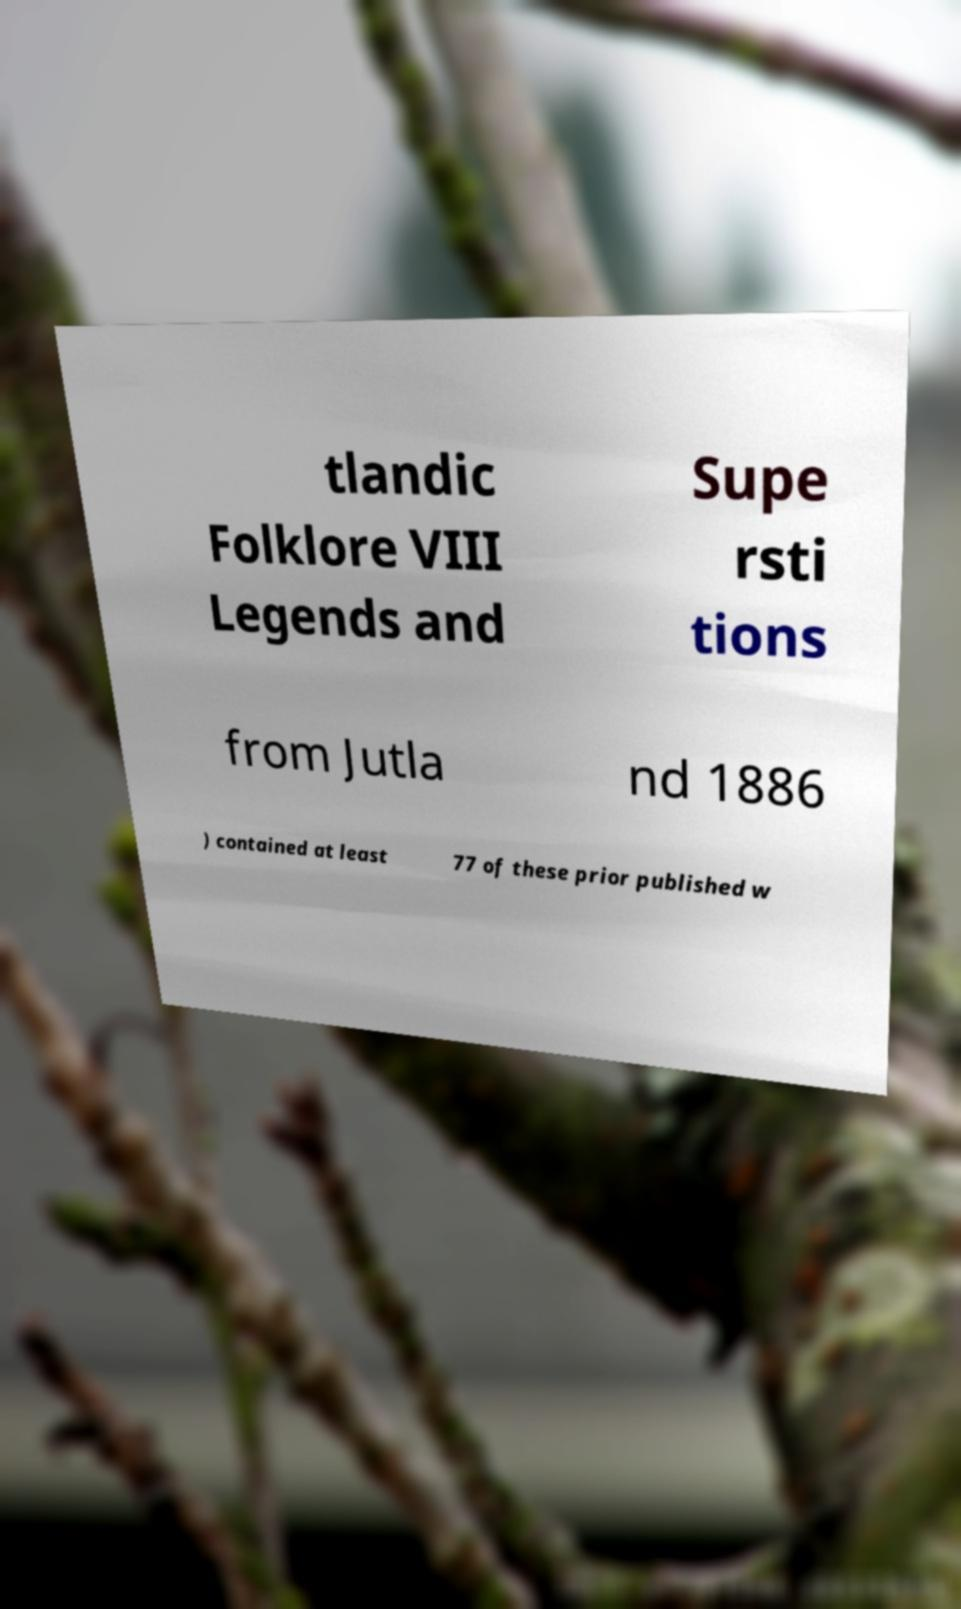I need the written content from this picture converted into text. Can you do that? tlandic Folklore VIII Legends and Supe rsti tions from Jutla nd 1886 ) contained at least 77 of these prior published w 